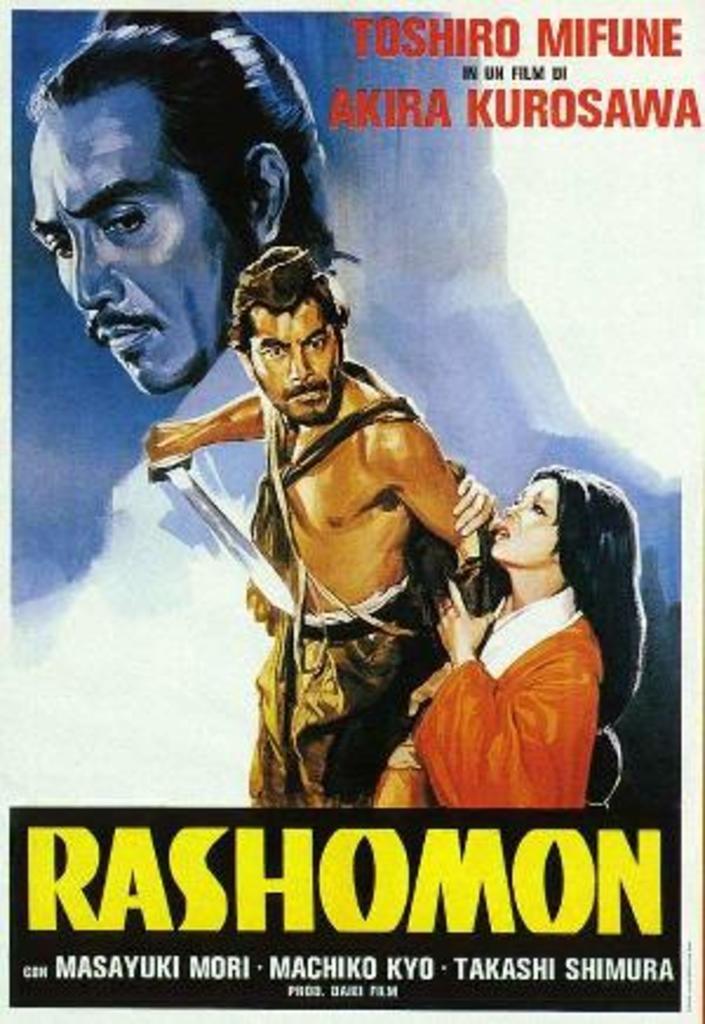What are some of the actors in this movie?
Keep it short and to the point. Toshiro mifune and akira kurosawa. What is the name of the film?
Offer a terse response. Rashomon. 